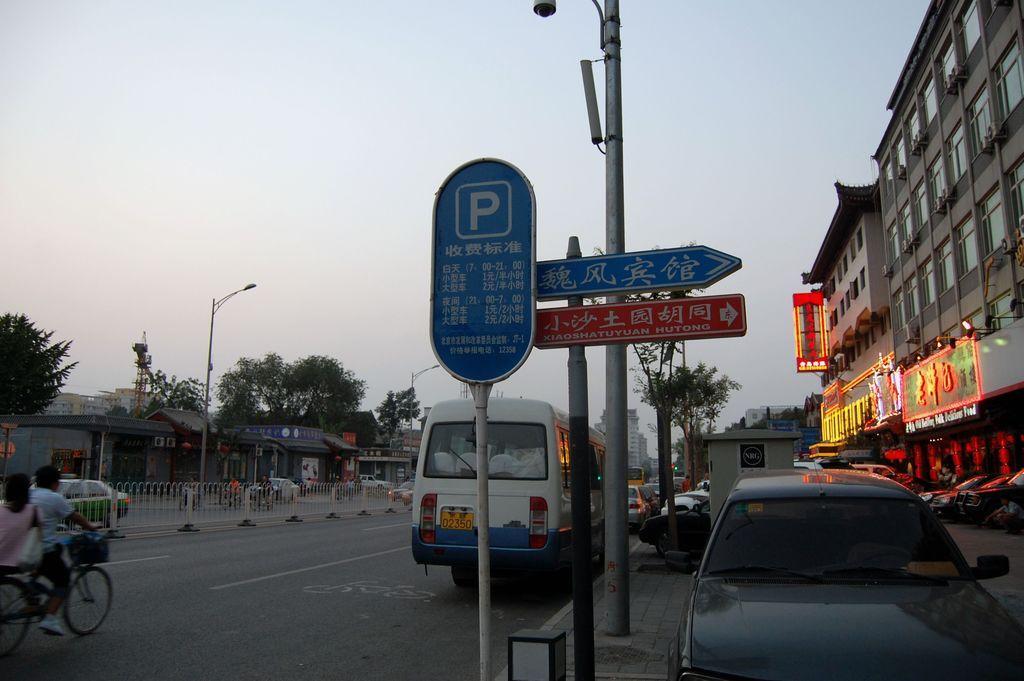Can you describe this image briefly? In this picture we can see vehicles, poles, boards, fence, trees, and buildings. There are two persons riding a bicycle on the road. In the background there is sky. 